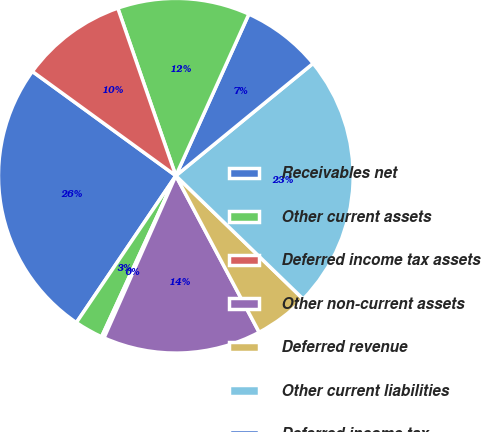Convert chart. <chart><loc_0><loc_0><loc_500><loc_500><pie_chart><fcel>Receivables net<fcel>Other current assets<fcel>Deferred income tax assets<fcel>Other non-current assets<fcel>Deferred revenue<fcel>Other current liabilities<fcel>Deferred income tax<fcel>Other non-current liabilities<fcel>Accumulated deficit<nl><fcel>25.53%<fcel>2.6%<fcel>0.24%<fcel>14.42%<fcel>4.97%<fcel>23.16%<fcel>7.33%<fcel>12.06%<fcel>9.69%<nl></chart> 